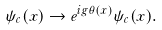Convert formula to latex. <formula><loc_0><loc_0><loc_500><loc_500>\psi _ { c } ( x ) \rightarrow e ^ { i g \theta ( x ) } \psi _ { c } ( x ) .</formula> 